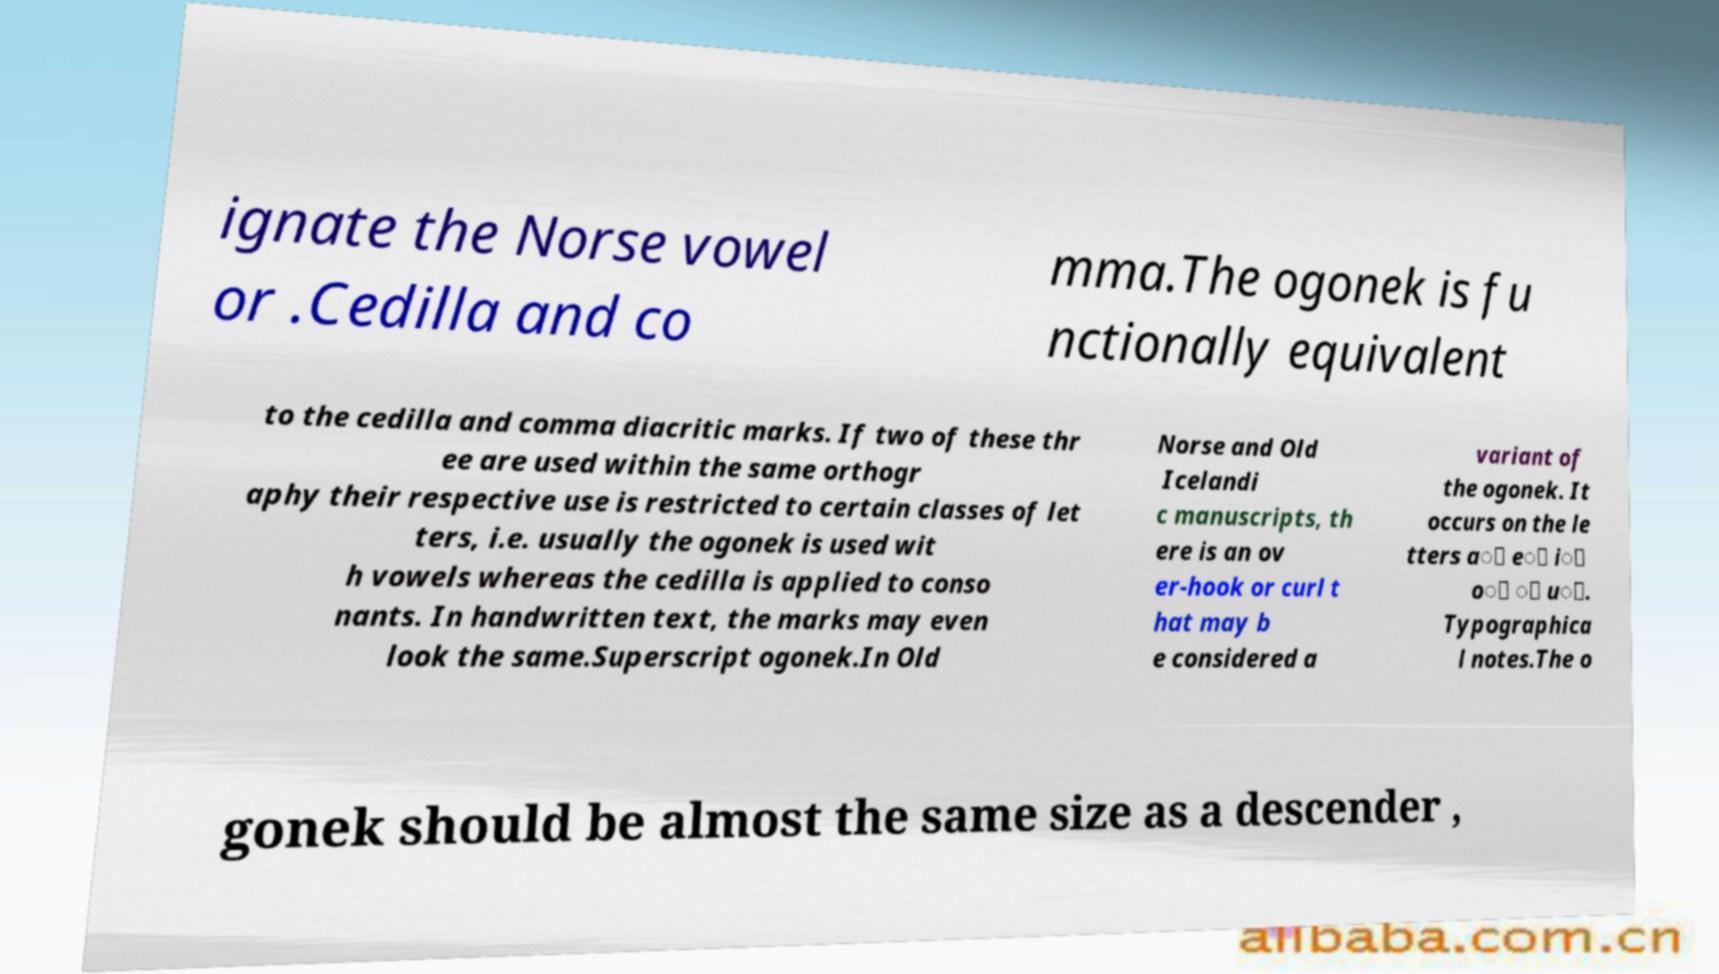Can you read and provide the text displayed in the image?This photo seems to have some interesting text. Can you extract and type it out for me? ignate the Norse vowel or .Cedilla and co mma.The ogonek is fu nctionally equivalent to the cedilla and comma diacritic marks. If two of these thr ee are used within the same orthogr aphy their respective use is restricted to certain classes of let ters, i.e. usually the ogonek is used wit h vowels whereas the cedilla is applied to conso nants. In handwritten text, the marks may even look the same.Superscript ogonek.In Old Norse and Old Icelandi c manuscripts, th ere is an ov er-hook or curl t hat may b e considered a variant of the ogonek. It occurs on the le tters a᷎ e᷎ i᷎ o᷎ ᷎ u᷎. Typographica l notes.The o gonek should be almost the same size as a descender , 